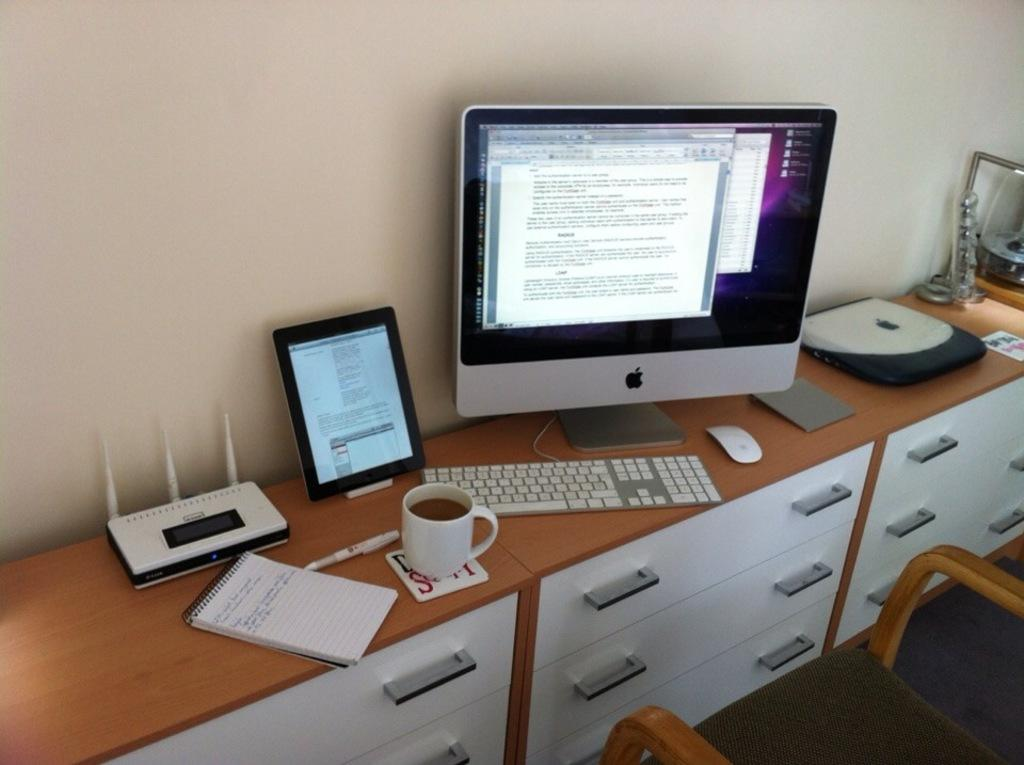What is the main piece of furniture in the image? There is a big table in the image. What items can be seen on the table? A book, a CPU, a monitor, a keyboard, and a mouse are placed on the table. Are there any other objects on the table besides the mentioned items? Yes, there are additional objects on the table. What is located in the right bottom of the image? There is a chair in the right bottom of the image. What type of ornament is hanging from the ceiling in the image? There is no ornament hanging from the ceiling in the image. What religious symbols can be seen on the table in the image? There are no religious symbols present in the image. 